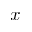<formula> <loc_0><loc_0><loc_500><loc_500>x</formula> 